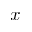<formula> <loc_0><loc_0><loc_500><loc_500>x</formula> 